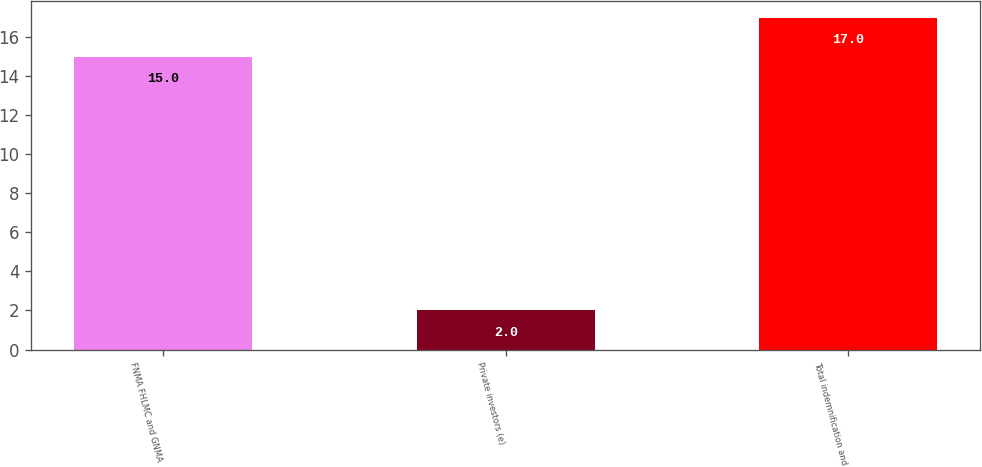<chart> <loc_0><loc_0><loc_500><loc_500><bar_chart><fcel>FNMA FHLMC and GNMA<fcel>Private investors (e)<fcel>Total indemnification and<nl><fcel>15<fcel>2<fcel>17<nl></chart> 